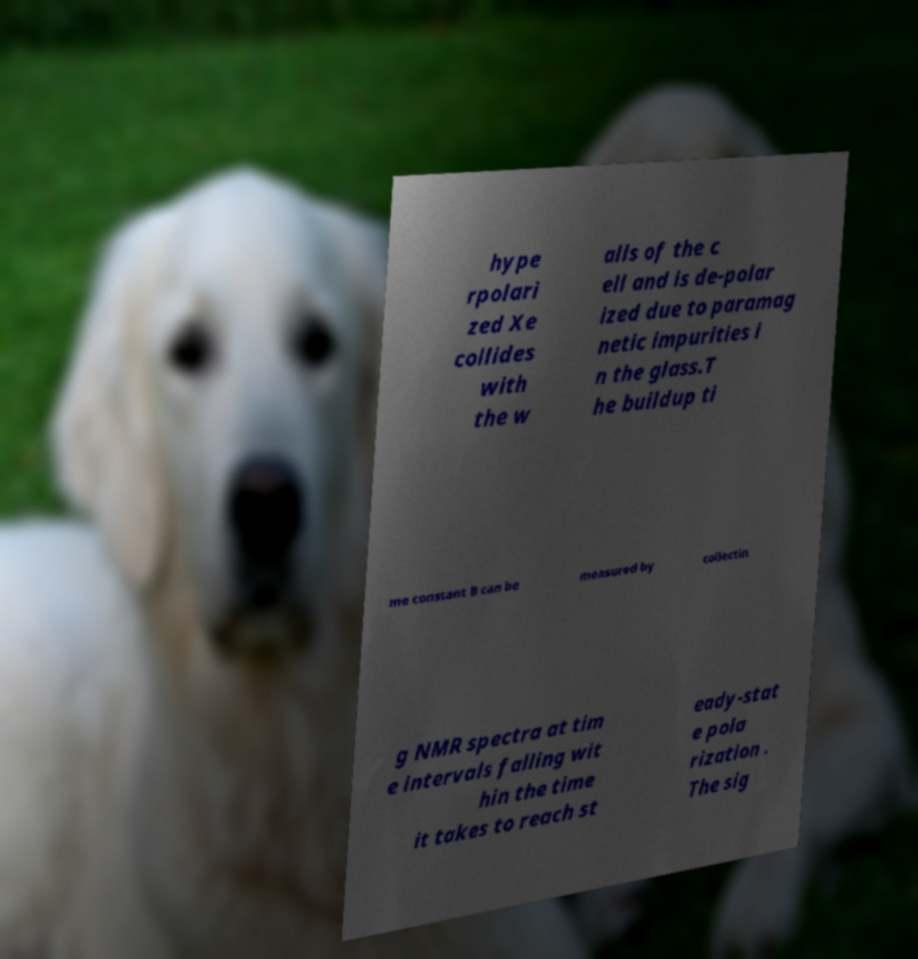Please read and relay the text visible in this image. What does it say? hype rpolari zed Xe collides with the w alls of the c ell and is de-polar ized due to paramag netic impurities i n the glass.T he buildup ti me constant B can be measured by collectin g NMR spectra at tim e intervals falling wit hin the time it takes to reach st eady-stat e pola rization . The sig 